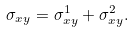<formula> <loc_0><loc_0><loc_500><loc_500>\sigma _ { x y } = \sigma _ { x y } ^ { 1 } + \sigma _ { x y } ^ { 2 } .</formula> 